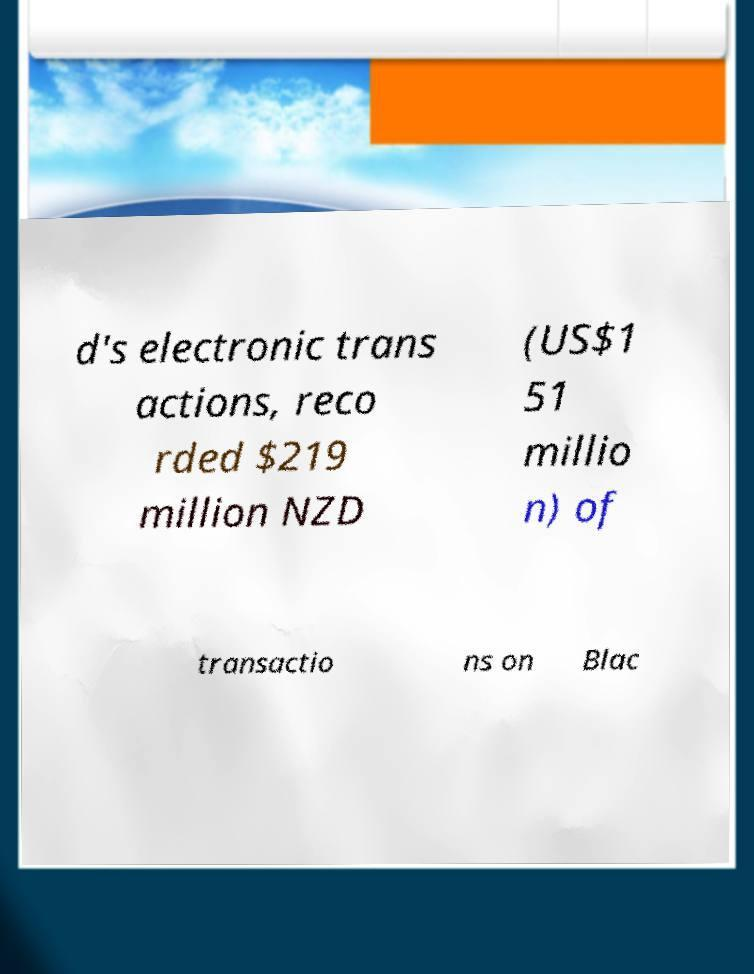Could you assist in decoding the text presented in this image and type it out clearly? d's electronic trans actions, reco rded $219 million NZD (US$1 51 millio n) of transactio ns on Blac 